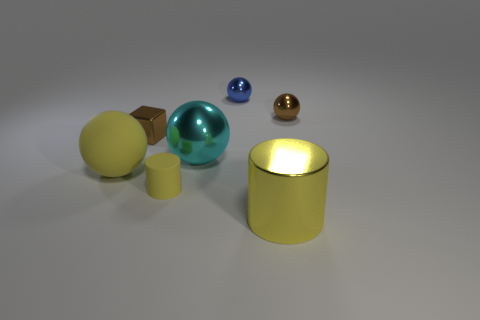Add 2 yellow metal things. How many objects exist? 9 Subtract all red cylinders. Subtract all gray blocks. How many cylinders are left? 2 Subtract all spheres. How many objects are left? 3 Add 2 brown things. How many brown things are left? 4 Add 6 small yellow matte things. How many small yellow matte things exist? 7 Subtract 0 blue blocks. How many objects are left? 7 Subtract all large balls. Subtract all big shiny balls. How many objects are left? 4 